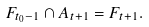Convert formula to latex. <formula><loc_0><loc_0><loc_500><loc_500>F _ { t _ { 0 } - 1 } \cap A _ { t + 1 } = F _ { t + 1 } .</formula> 